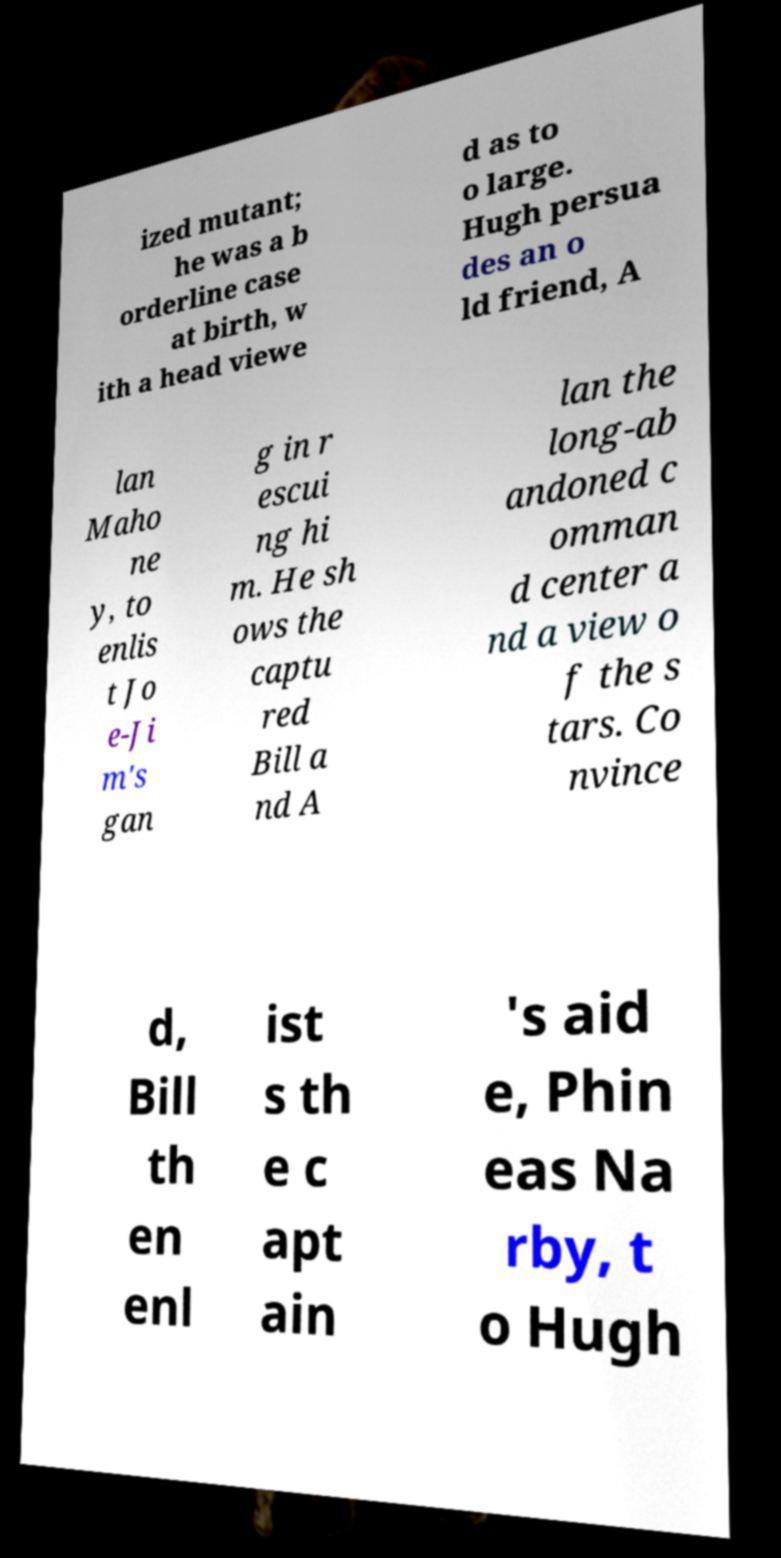Could you extract and type out the text from this image? ized mutant; he was a b orderline case at birth, w ith a head viewe d as to o large. Hugh persua des an o ld friend, A lan Maho ne y, to enlis t Jo e-Ji m's gan g in r escui ng hi m. He sh ows the captu red Bill a nd A lan the long-ab andoned c omman d center a nd a view o f the s tars. Co nvince d, Bill th en enl ist s th e c apt ain 's aid e, Phin eas Na rby, t o Hugh 